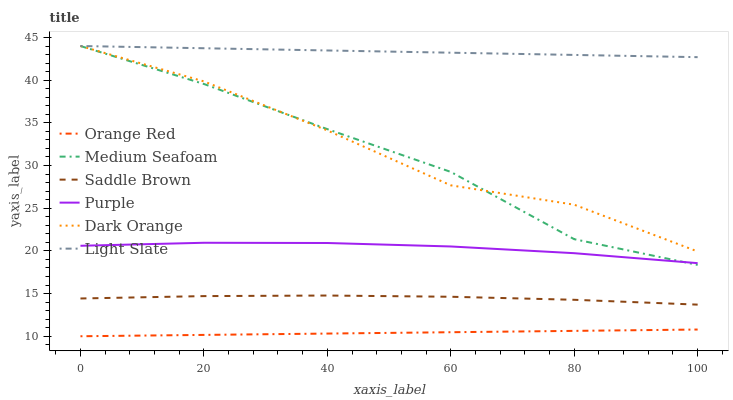Does Orange Red have the minimum area under the curve?
Answer yes or no. Yes. Does Light Slate have the maximum area under the curve?
Answer yes or no. Yes. Does Purple have the minimum area under the curve?
Answer yes or no. No. Does Purple have the maximum area under the curve?
Answer yes or no. No. Is Orange Red the smoothest?
Answer yes or no. Yes. Is Dark Orange the roughest?
Answer yes or no. Yes. Is Purple the smoothest?
Answer yes or no. No. Is Purple the roughest?
Answer yes or no. No. Does Orange Red have the lowest value?
Answer yes or no. Yes. Does Purple have the lowest value?
Answer yes or no. No. Does Medium Seafoam have the highest value?
Answer yes or no. Yes. Does Purple have the highest value?
Answer yes or no. No. Is Saddle Brown less than Purple?
Answer yes or no. Yes. Is Saddle Brown greater than Orange Red?
Answer yes or no. Yes. Does Dark Orange intersect Light Slate?
Answer yes or no. Yes. Is Dark Orange less than Light Slate?
Answer yes or no. No. Is Dark Orange greater than Light Slate?
Answer yes or no. No. Does Saddle Brown intersect Purple?
Answer yes or no. No. 